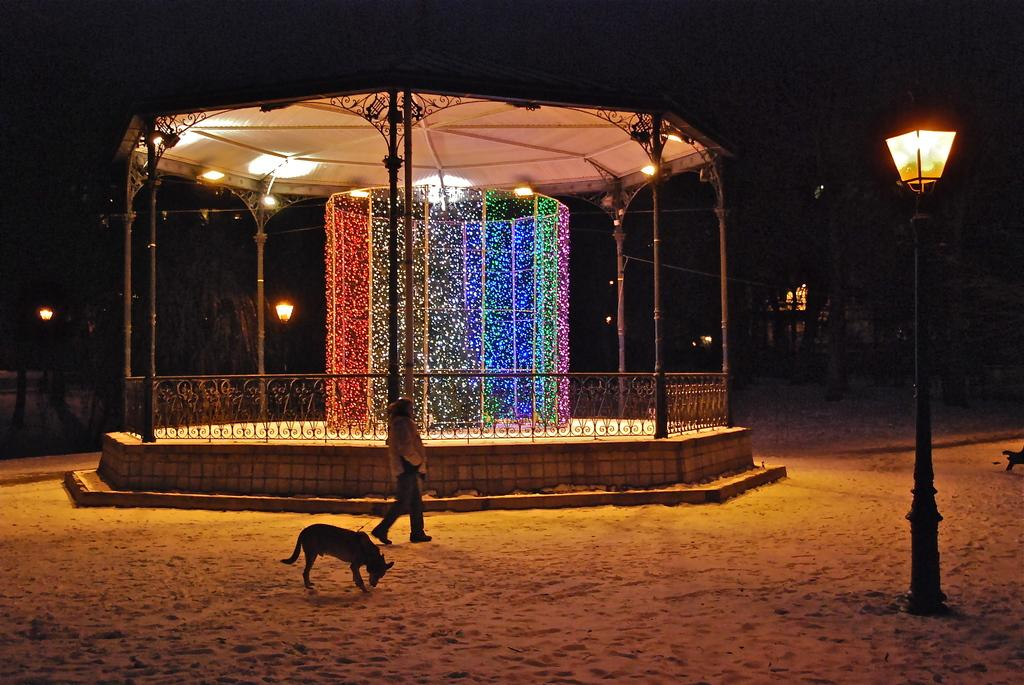What is the person in the image doing? There is a person walking in the image. What animal is present in the image? There is a dog in the image. What structure has lights in the image? There is a shed with lights in the image. What type of poles can be seen in the image? There are light poles in the image. What type of ground is visible at the bottom of the image? There is sand at the bottom of the image. What type of disease is the dog suffering from in the image? There is no indication of any disease in the image; the dog appears to be healthy. What letters are visible on the shed in the image? There are no letters visible on the shed in the image. 